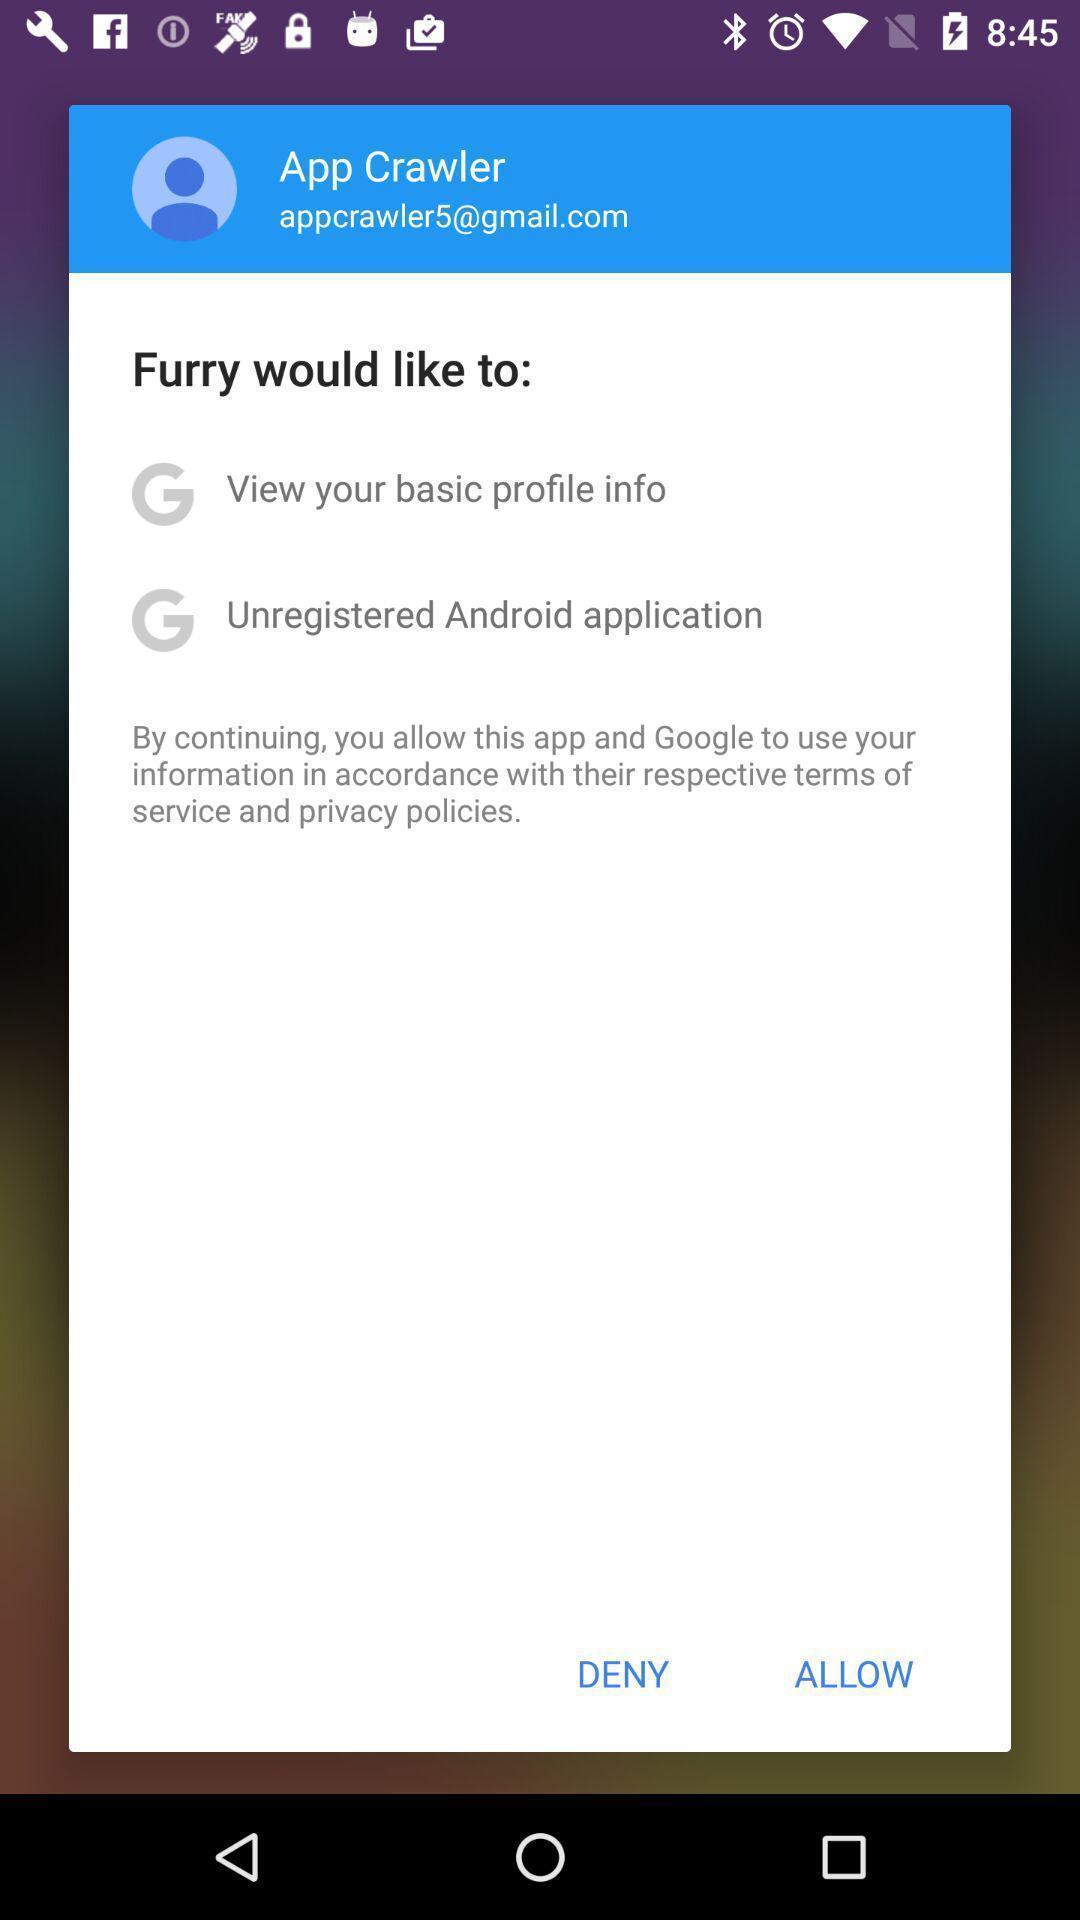Explain the elements present in this screenshot. Popup showing options to select. 